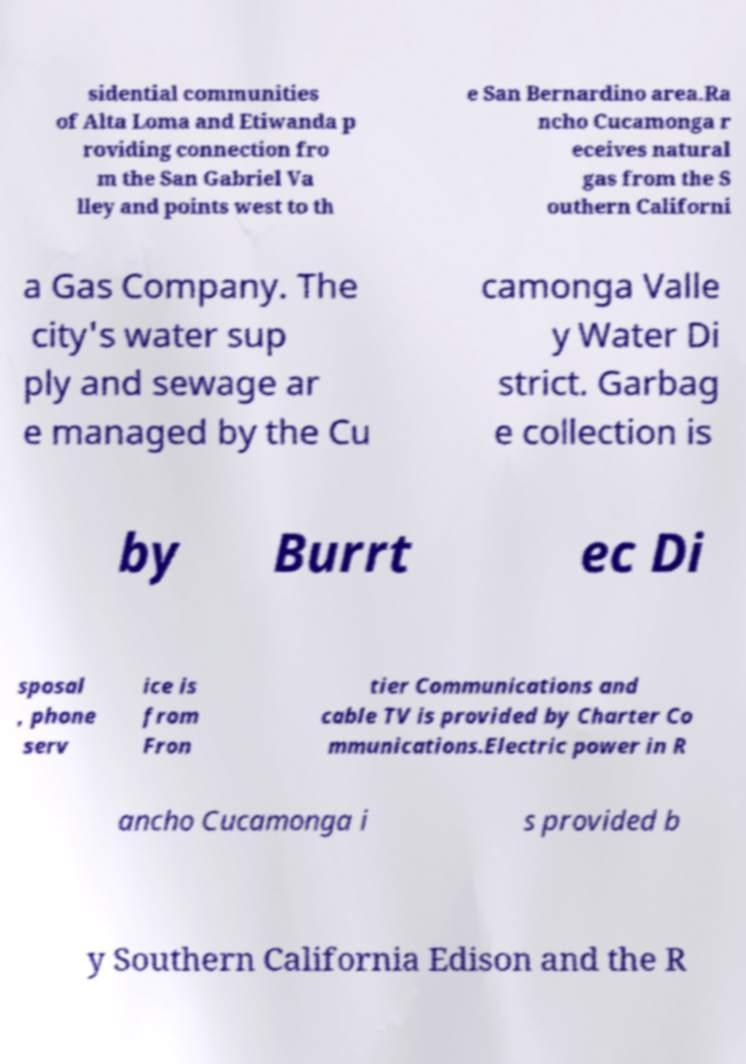Can you read and provide the text displayed in the image?This photo seems to have some interesting text. Can you extract and type it out for me? sidential communities of Alta Loma and Etiwanda p roviding connection fro m the San Gabriel Va lley and points west to th e San Bernardino area.Ra ncho Cucamonga r eceives natural gas from the S outhern Californi a Gas Company. The city's water sup ply and sewage ar e managed by the Cu camonga Valle y Water Di strict. Garbag e collection is by Burrt ec Di sposal , phone serv ice is from Fron tier Communications and cable TV is provided by Charter Co mmunications.Electric power in R ancho Cucamonga i s provided b y Southern California Edison and the R 